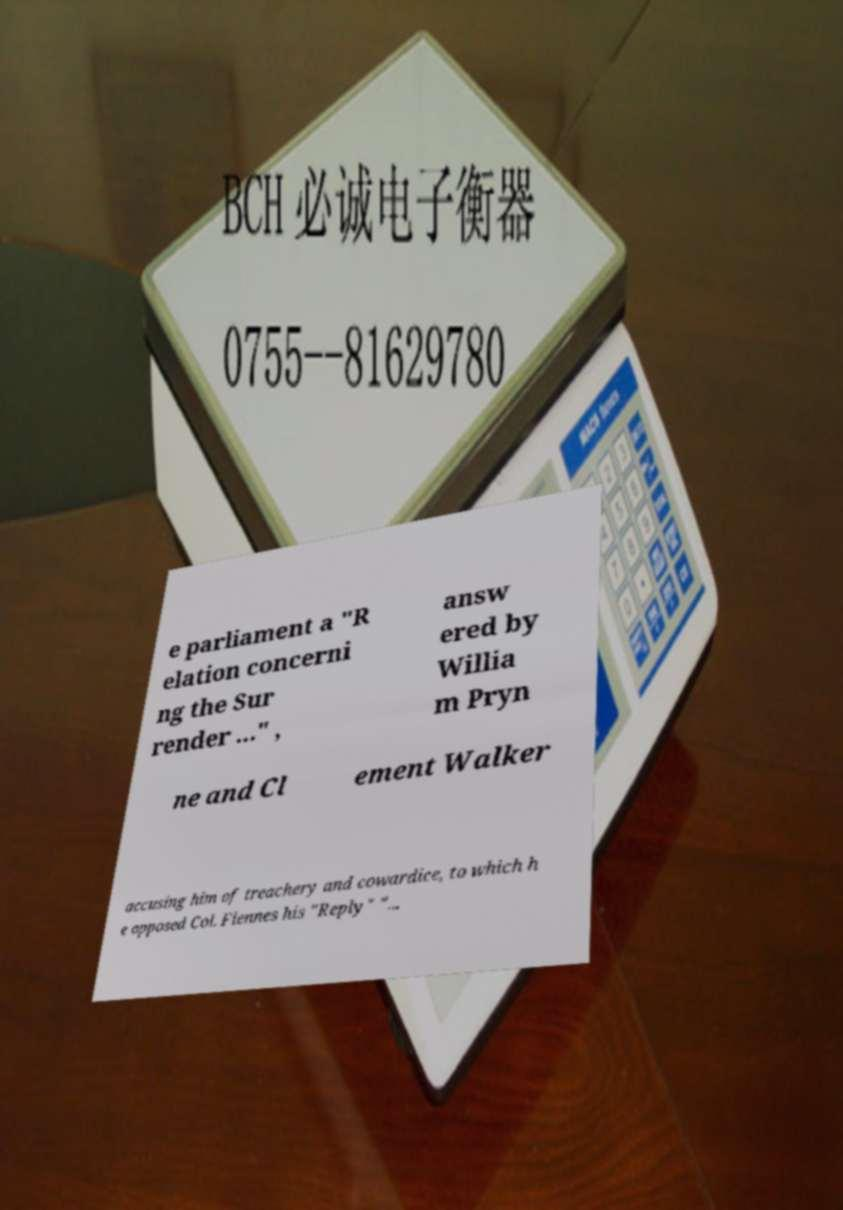There's text embedded in this image that I need extracted. Can you transcribe it verbatim? e parliament a "R elation concerni ng the Sur render ..." , answ ered by Willia m Pryn ne and Cl ement Walker accusing him of treachery and cowardice, to which h e opposed Col. Fiennes his "Reply" "... 